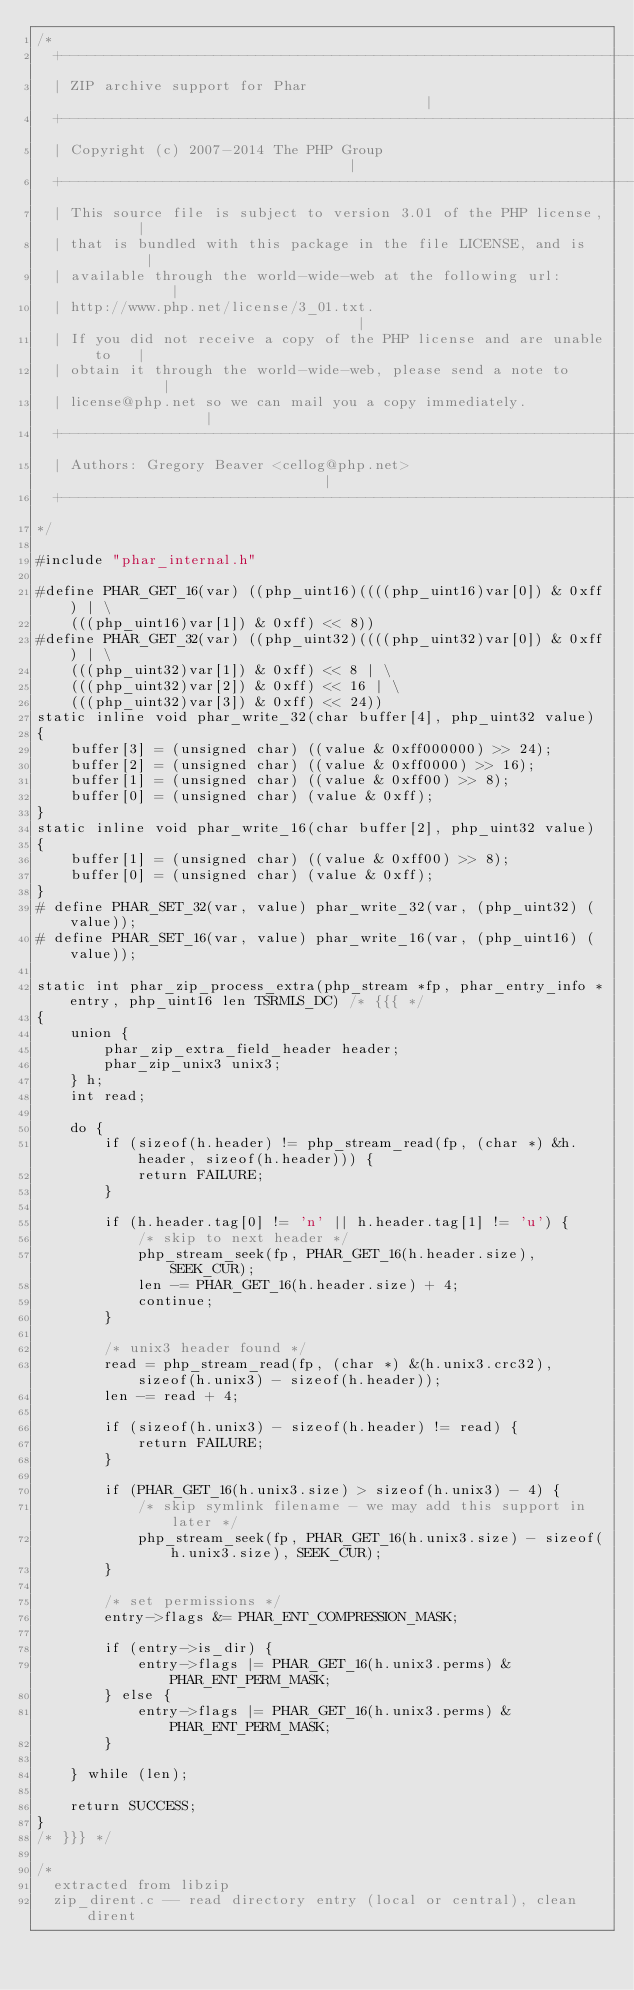<code> <loc_0><loc_0><loc_500><loc_500><_C_>/*
  +----------------------------------------------------------------------+
  | ZIP archive support for Phar                                         |
  +----------------------------------------------------------------------+
  | Copyright (c) 2007-2014 The PHP Group                                |
  +----------------------------------------------------------------------+
  | This source file is subject to version 3.01 of the PHP license,      |
  | that is bundled with this package in the file LICENSE, and is        |
  | available through the world-wide-web at the following url:           |
  | http://www.php.net/license/3_01.txt.                                 |
  | If you did not receive a copy of the PHP license and are unable to   |
  | obtain it through the world-wide-web, please send a note to          |
  | license@php.net so we can mail you a copy immediately.               |
  +----------------------------------------------------------------------+
  | Authors: Gregory Beaver <cellog@php.net>                             |
  +----------------------------------------------------------------------+
*/

#include "phar_internal.h"

#define PHAR_GET_16(var) ((php_uint16)((((php_uint16)var[0]) & 0xff) | \
	(((php_uint16)var[1]) & 0xff) << 8))
#define PHAR_GET_32(var) ((php_uint32)((((php_uint32)var[0]) & 0xff) | \
	(((php_uint32)var[1]) & 0xff) << 8 | \
	(((php_uint32)var[2]) & 0xff) << 16 | \
	(((php_uint32)var[3]) & 0xff) << 24))
static inline void phar_write_32(char buffer[4], php_uint32 value)
{
	buffer[3] = (unsigned char) ((value & 0xff000000) >> 24);
	buffer[2] = (unsigned char) ((value & 0xff0000) >> 16);
	buffer[1] = (unsigned char) ((value & 0xff00) >> 8);
	buffer[0] = (unsigned char) (value & 0xff);
}
static inline void phar_write_16(char buffer[2], php_uint32 value)
{
	buffer[1] = (unsigned char) ((value & 0xff00) >> 8);
	buffer[0] = (unsigned char) (value & 0xff);
}
# define PHAR_SET_32(var, value) phar_write_32(var, (php_uint32) (value));
# define PHAR_SET_16(var, value) phar_write_16(var, (php_uint16) (value));

static int phar_zip_process_extra(php_stream *fp, phar_entry_info *entry, php_uint16 len TSRMLS_DC) /* {{{ */
{
	union {
		phar_zip_extra_field_header header;
		phar_zip_unix3 unix3;
	} h;
	int read;

	do {
		if (sizeof(h.header) != php_stream_read(fp, (char *) &h.header, sizeof(h.header))) {
			return FAILURE;
		}

		if (h.header.tag[0] != 'n' || h.header.tag[1] != 'u') {
			/* skip to next header */
			php_stream_seek(fp, PHAR_GET_16(h.header.size), SEEK_CUR);
			len -= PHAR_GET_16(h.header.size) + 4;
			continue;
		}

		/* unix3 header found */
		read = php_stream_read(fp, (char *) &(h.unix3.crc32), sizeof(h.unix3) - sizeof(h.header));
		len -= read + 4;

		if (sizeof(h.unix3) - sizeof(h.header) != read) {
			return FAILURE;
		}

		if (PHAR_GET_16(h.unix3.size) > sizeof(h.unix3) - 4) {
			/* skip symlink filename - we may add this support in later */
			php_stream_seek(fp, PHAR_GET_16(h.unix3.size) - sizeof(h.unix3.size), SEEK_CUR);
		}

		/* set permissions */
		entry->flags &= PHAR_ENT_COMPRESSION_MASK;

		if (entry->is_dir) {
			entry->flags |= PHAR_GET_16(h.unix3.perms) & PHAR_ENT_PERM_MASK;
		} else {
			entry->flags |= PHAR_GET_16(h.unix3.perms) & PHAR_ENT_PERM_MASK;
		}

	} while (len);

	return SUCCESS;
}
/* }}} */

/*
  extracted from libzip
  zip_dirent.c -- read directory entry (local or central), clean dirent</code> 